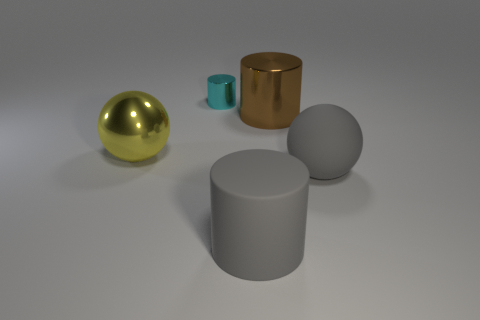What number of other objects are there of the same material as the big gray cylinder?
Provide a succinct answer. 1. Are there any other things that have the same size as the cyan object?
Offer a very short reply. No. The other large object that is made of the same material as the brown object is what color?
Provide a short and direct response. Yellow. Is the large brown cylinder made of the same material as the big ball on the left side of the tiny metal object?
Make the answer very short. Yes. How many things are big gray cylinders or metal objects?
Give a very brief answer. 4. There is a big cylinder that is the same color as the big matte sphere; what is its material?
Keep it short and to the point. Rubber. Is there a big thing of the same shape as the small shiny object?
Keep it short and to the point. Yes. How many tiny cylinders are in front of the big gray rubber cylinder?
Your answer should be very brief. 0. What material is the large gray object that is behind the big gray cylinder that is to the left of the big gray ball made of?
Offer a very short reply. Rubber. There is a yellow ball that is the same size as the gray matte sphere; what is it made of?
Your answer should be very brief. Metal. 